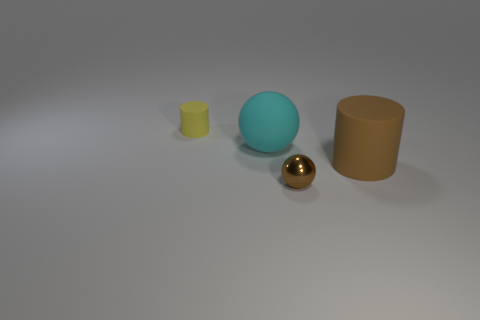What materials do the objects depicted in the image appear to be made from? The objects seem to be computer-generated and have different textures. The balls, for instance, have what looks like a shiny metallic and a matte finish, suggesting different materials. The cylinders appear to have matte surfaces as well, which might indicate a non-reflective material like plastic or rubber in a real-world setting. 